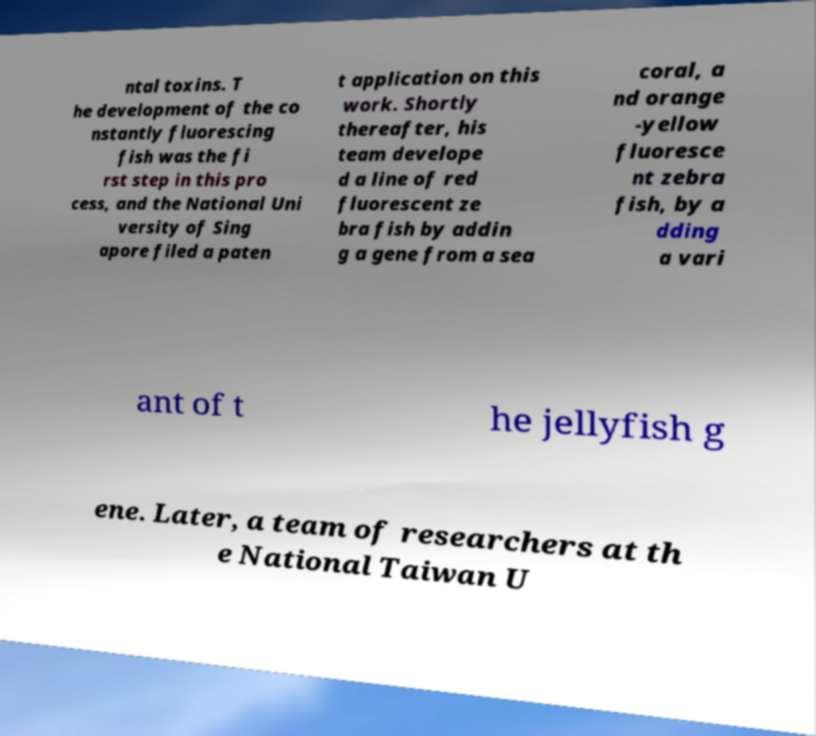I need the written content from this picture converted into text. Can you do that? ntal toxins. T he development of the co nstantly fluorescing fish was the fi rst step in this pro cess, and the National Uni versity of Sing apore filed a paten t application on this work. Shortly thereafter, his team develope d a line of red fluorescent ze bra fish by addin g a gene from a sea coral, a nd orange -yellow fluoresce nt zebra fish, by a dding a vari ant of t he jellyfish g ene. Later, a team of researchers at th e National Taiwan U 